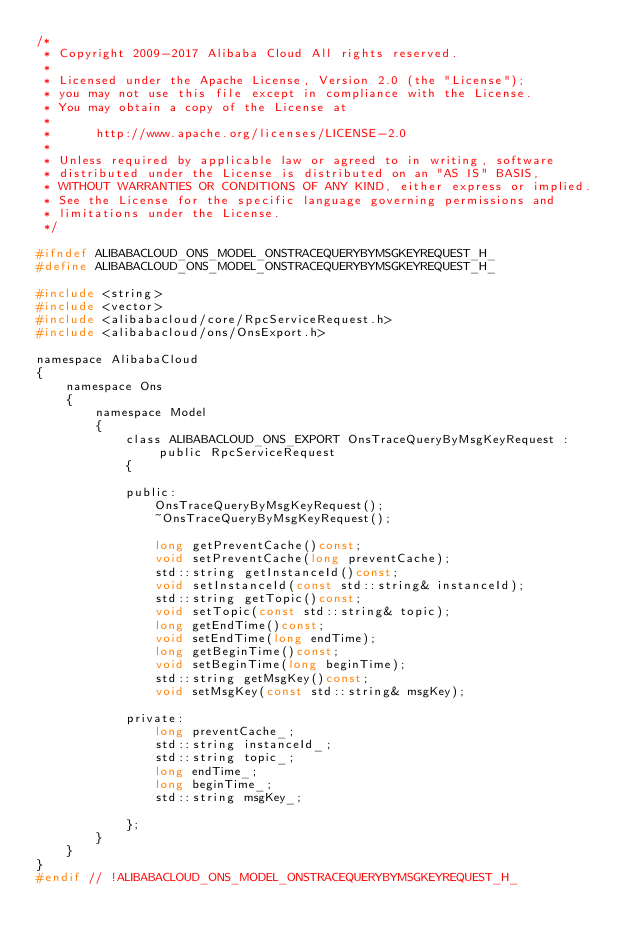<code> <loc_0><loc_0><loc_500><loc_500><_C_>/*
 * Copyright 2009-2017 Alibaba Cloud All rights reserved.
 * 
 * Licensed under the Apache License, Version 2.0 (the "License");
 * you may not use this file except in compliance with the License.
 * You may obtain a copy of the License at
 * 
 *      http://www.apache.org/licenses/LICENSE-2.0
 * 
 * Unless required by applicable law or agreed to in writing, software
 * distributed under the License is distributed on an "AS IS" BASIS,
 * WITHOUT WARRANTIES OR CONDITIONS OF ANY KIND, either express or implied.
 * See the License for the specific language governing permissions and
 * limitations under the License.
 */

#ifndef ALIBABACLOUD_ONS_MODEL_ONSTRACEQUERYBYMSGKEYREQUEST_H_
#define ALIBABACLOUD_ONS_MODEL_ONSTRACEQUERYBYMSGKEYREQUEST_H_

#include <string>
#include <vector>
#include <alibabacloud/core/RpcServiceRequest.h>
#include <alibabacloud/ons/OnsExport.h>

namespace AlibabaCloud
{
	namespace Ons
	{
		namespace Model
		{
			class ALIBABACLOUD_ONS_EXPORT OnsTraceQueryByMsgKeyRequest : public RpcServiceRequest
			{

			public:
				OnsTraceQueryByMsgKeyRequest();
				~OnsTraceQueryByMsgKeyRequest();

				long getPreventCache()const;
				void setPreventCache(long preventCache);
				std::string getInstanceId()const;
				void setInstanceId(const std::string& instanceId);
				std::string getTopic()const;
				void setTopic(const std::string& topic);
				long getEndTime()const;
				void setEndTime(long endTime);
				long getBeginTime()const;
				void setBeginTime(long beginTime);
				std::string getMsgKey()const;
				void setMsgKey(const std::string& msgKey);

            private:
				long preventCache_;
				std::string instanceId_;
				std::string topic_;
				long endTime_;
				long beginTime_;
				std::string msgKey_;

			};
		}
	}
}
#endif // !ALIBABACLOUD_ONS_MODEL_ONSTRACEQUERYBYMSGKEYREQUEST_H_</code> 